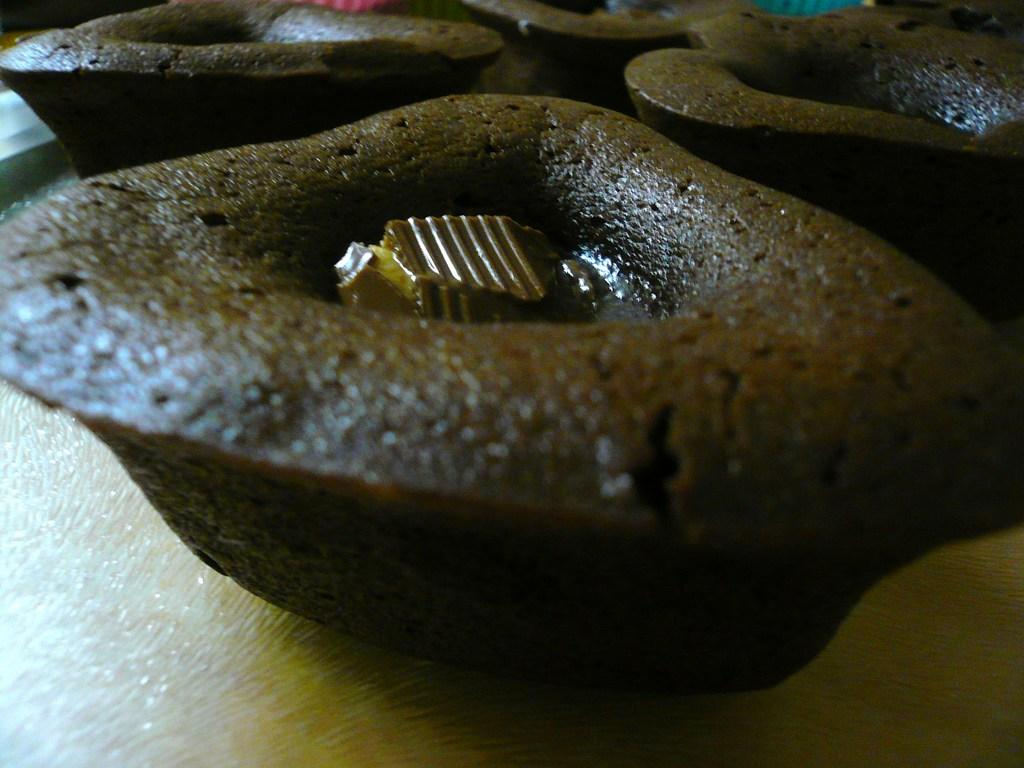What types of items can be seen in the image? There are eatable things in the image. Where are the eatable things located? The eatable things are placed on a surface. Can you see a snail starting to crawl on the surface in the image? There is no snail present in the image, so it cannot be seen starting to crawl on the surface. 